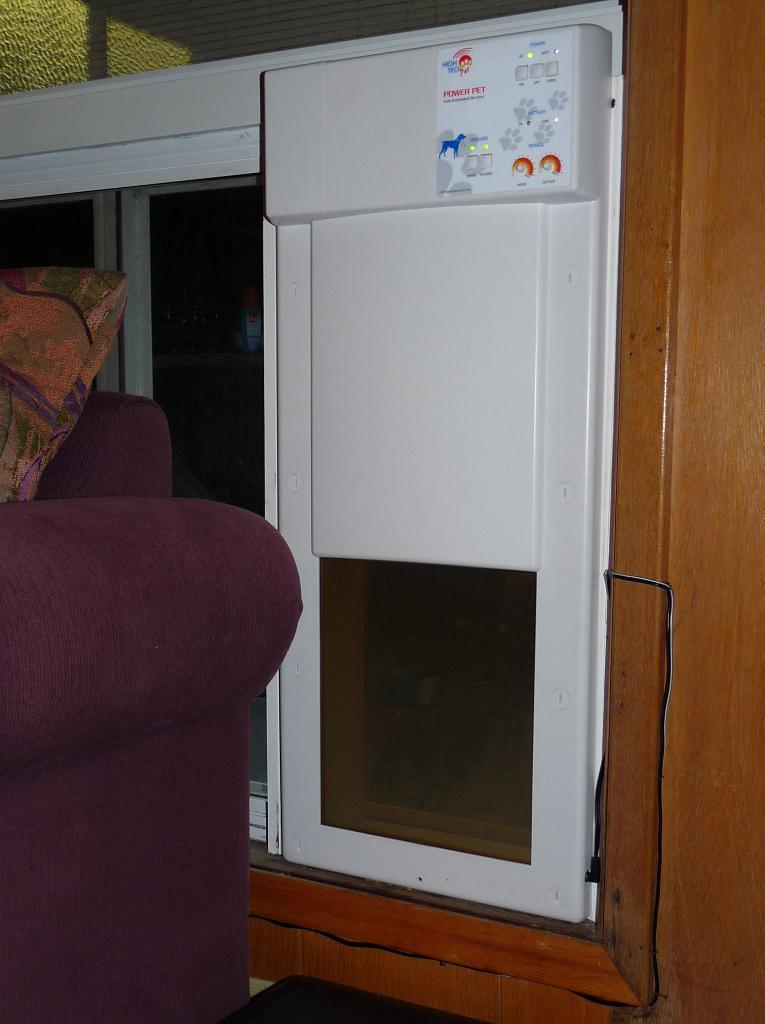Please provide a concise description of this image. In this image we can see an electronic device attached to the wall. There are windows. To the left side of the image there is a chair. 